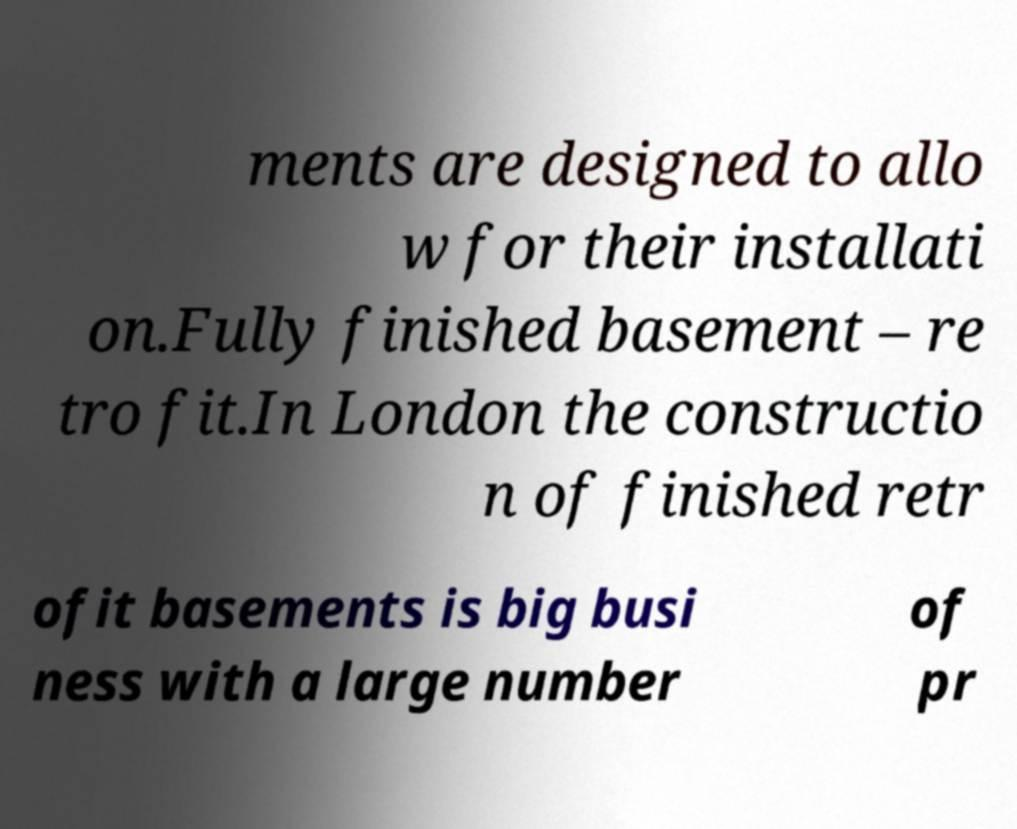Can you read and provide the text displayed in the image?This photo seems to have some interesting text. Can you extract and type it out for me? ments are designed to allo w for their installati on.Fully finished basement – re tro fit.In London the constructio n of finished retr ofit basements is big busi ness with a large number of pr 